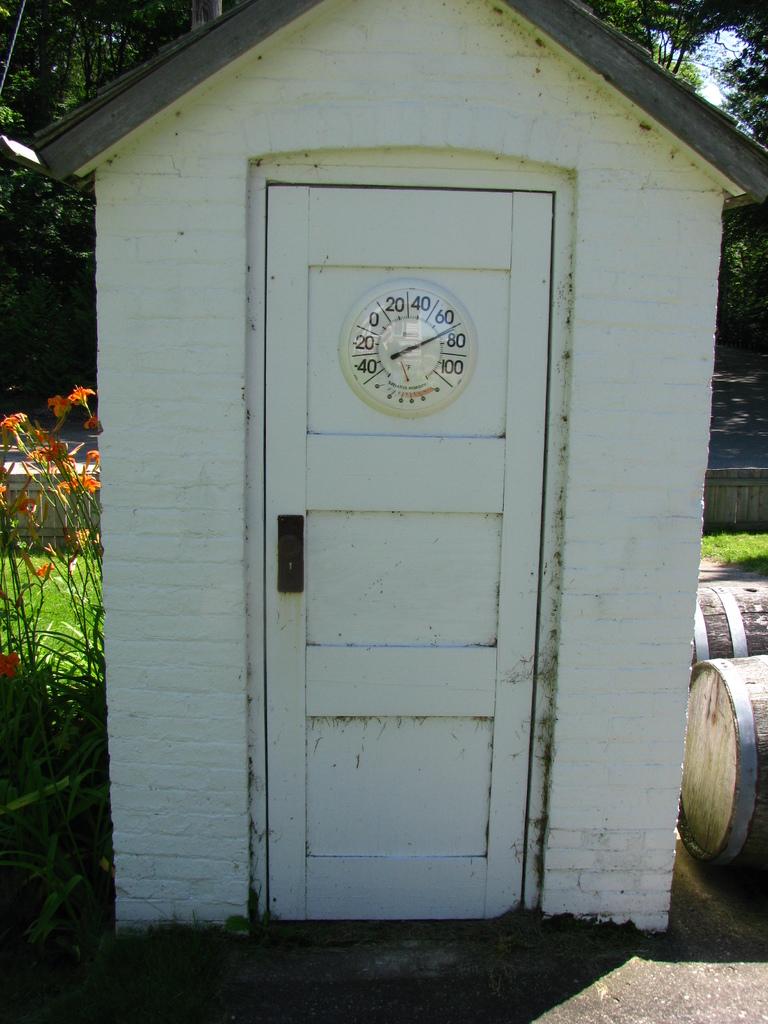What is the temperature shown on the outdoor thermometer?
Keep it short and to the point. 70. 